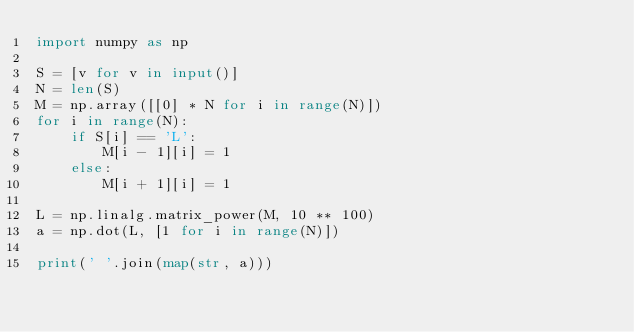Convert code to text. <code><loc_0><loc_0><loc_500><loc_500><_Python_>import numpy as np

S = [v for v in input()]
N = len(S)
M = np.array([[0] * N for i in range(N)])
for i in range(N):
    if S[i] == 'L':
        M[i - 1][i] = 1
    else:
        M[i + 1][i] = 1

L = np.linalg.matrix_power(M, 10 ** 100)
a = np.dot(L, [1 for i in range(N)])

print(' '.join(map(str, a)))</code> 